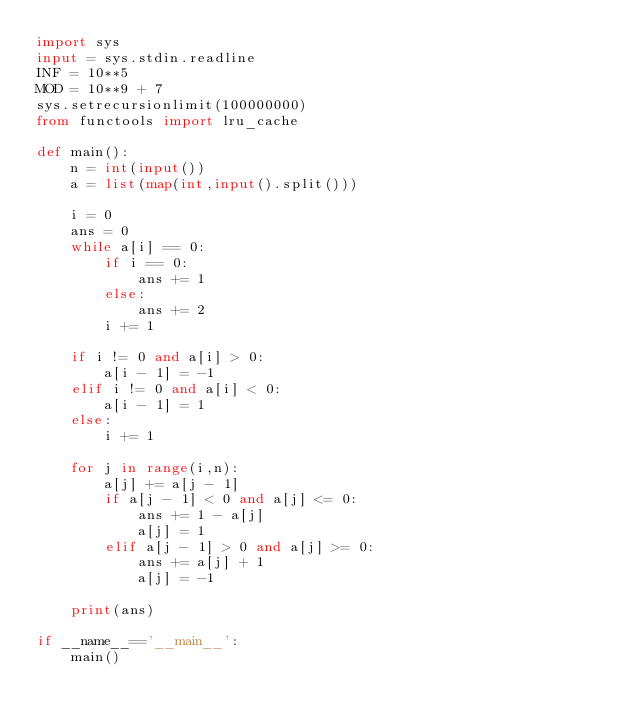<code> <loc_0><loc_0><loc_500><loc_500><_Python_>import sys
input = sys.stdin.readline
INF = 10**5
MOD = 10**9 + 7
sys.setrecursionlimit(100000000)
from functools import lru_cache

def main():
    n = int(input())
    a = list(map(int,input().split()))
    
    i = 0
    ans = 0
    while a[i] == 0:
        if i == 0:
            ans += 1
        else:
            ans += 2
        i += 1  
    
    if i != 0 and a[i] > 0:
        a[i - 1] = -1
    elif i != 0 and a[i] < 0:
        a[i - 1] = 1
    else:
        i += 1

    for j in range(i,n):
        a[j] += a[j - 1]
        if a[j - 1] < 0 and a[j] <= 0:
            ans += 1 - a[j]
            a[j] = 1
        elif a[j - 1] > 0 and a[j] >= 0:
            ans += a[j] + 1
            a[j] = -1
    
    print(ans)

if __name__=='__main__':
    main() </code> 